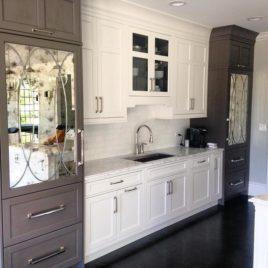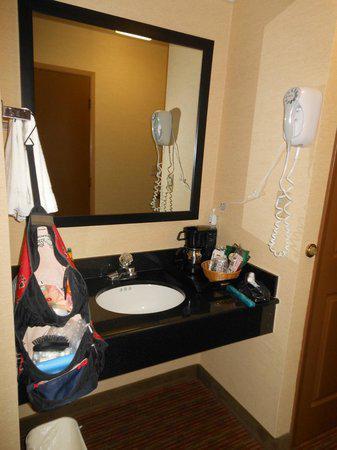The first image is the image on the left, the second image is the image on the right. Given the left and right images, does the statement "A mirror sits over the sink in the image on the right." hold true? Answer yes or no. Yes. The first image is the image on the left, the second image is the image on the right. Assess this claim about the two images: "There is a refrigerator next to a counter containing a wash basin.". Correct or not? Answer yes or no. No. 